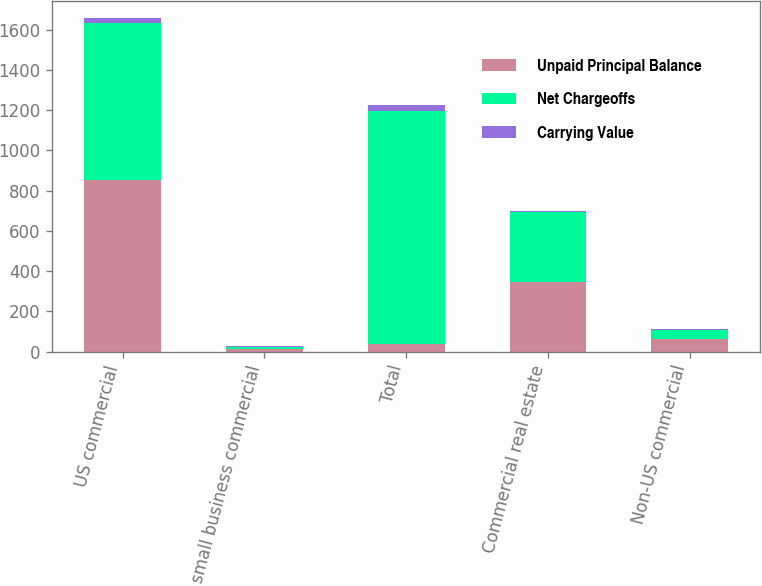Convert chart to OTSL. <chart><loc_0><loc_0><loc_500><loc_500><stacked_bar_chart><ecel><fcel>US commercial<fcel>US small business commercial<fcel>Total<fcel>Commercial real estate<fcel>Non-US commercial<nl><fcel>Unpaid Principal Balance<fcel>853<fcel>14<fcel>37.5<fcel>346<fcel>61<nl><fcel>Net Chargeoffs<fcel>779<fcel>11<fcel>1158<fcel>346<fcel>44<nl><fcel>Carrying Value<fcel>28<fcel>3<fcel>31<fcel>8<fcel>7<nl></chart> 